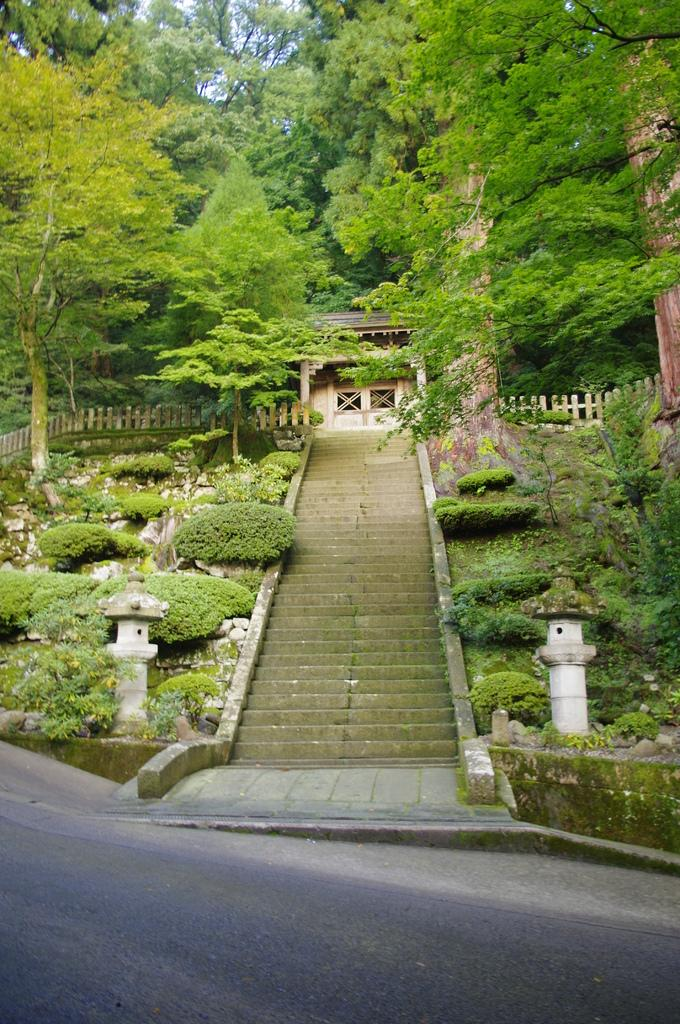What structures are present in the image? There are poles, steps, and a fence in the image. What type of vegetation can be seen in the image? There are plants and trees in the image. What is the main building in the image? There is a house in the center of the image. What is visible in the background of the image? There are trees in the background of the image. What type of eggs can be seen in the image? There are no eggs present in the image. What is the calculator used for in the image? There is no calculator present in the image. 